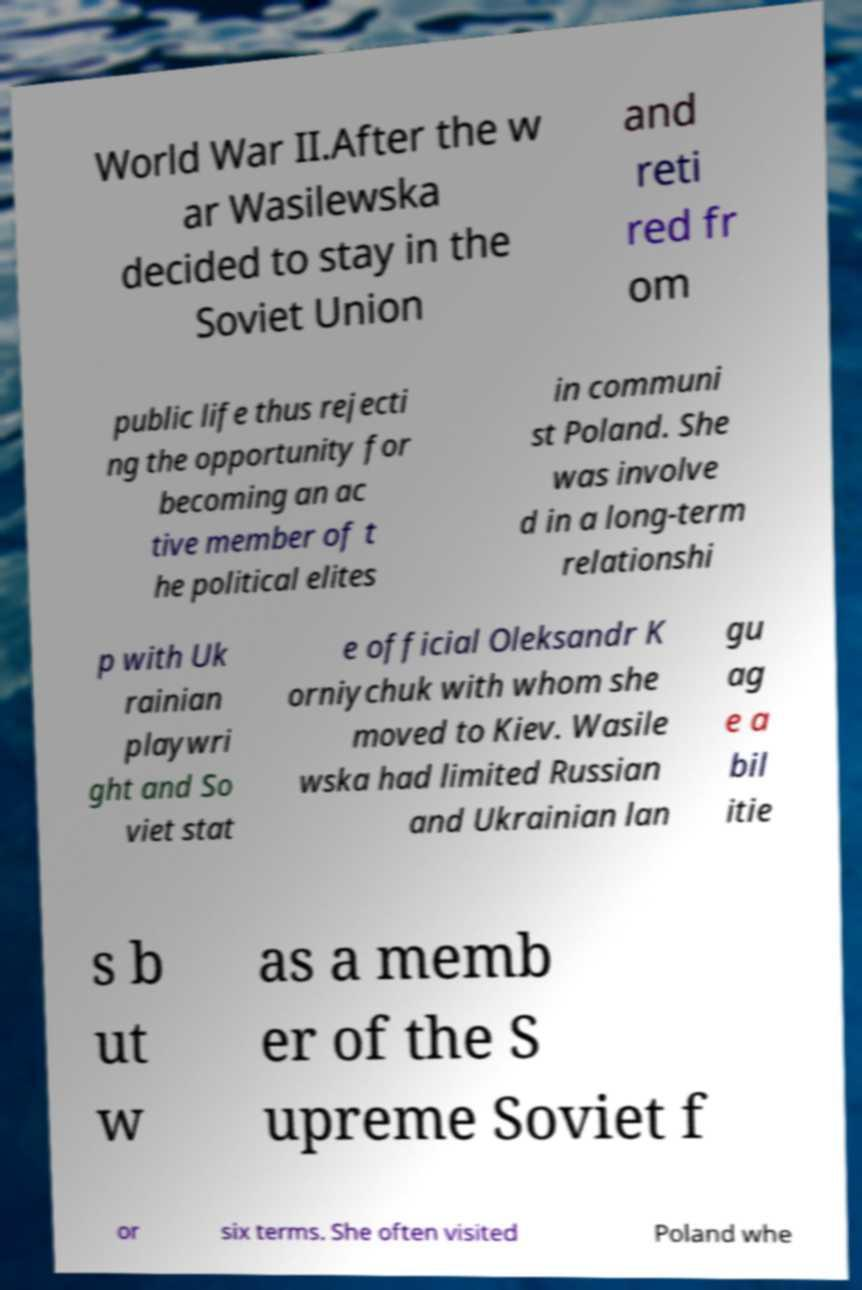Please identify and transcribe the text found in this image. World War II.After the w ar Wasilewska decided to stay in the Soviet Union and reti red fr om public life thus rejecti ng the opportunity for becoming an ac tive member of t he political elites in communi st Poland. She was involve d in a long-term relationshi p with Uk rainian playwri ght and So viet stat e official Oleksandr K orniychuk with whom she moved to Kiev. Wasile wska had limited Russian and Ukrainian lan gu ag e a bil itie s b ut w as a memb er of the S upreme Soviet f or six terms. She often visited Poland whe 